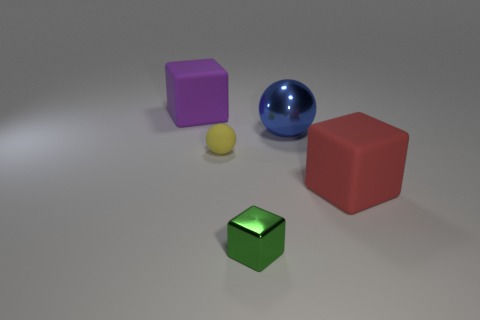What is the size of the blue shiny object that is the same shape as the small yellow rubber object?
Your answer should be compact. Large. Is the size of the red object the same as the sphere in front of the big metallic sphere?
Offer a very short reply. No. What is the color of the other thing that is the same shape as the small yellow matte object?
Give a very brief answer. Blue. Do the rubber block in front of the blue object and the sphere that is behind the tiny matte thing have the same size?
Your answer should be very brief. Yes. Is the green object the same shape as the big red thing?
Ensure brevity in your answer.  Yes. What number of things are either cubes behind the yellow rubber ball or big green rubber blocks?
Keep it short and to the point. 1. Is there another tiny thing of the same shape as the purple object?
Provide a succinct answer. Yes. Are there the same number of yellow rubber balls that are on the right side of the small yellow object and small blue cylinders?
Offer a very short reply. Yes. What number of yellow rubber balls have the same size as the red object?
Keep it short and to the point. 0. There is a tiny yellow thing; what number of large red blocks are behind it?
Your response must be concise. 0. 